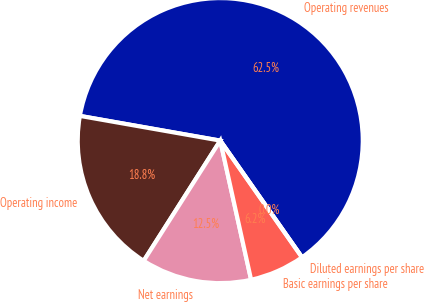Convert chart. <chart><loc_0><loc_0><loc_500><loc_500><pie_chart><fcel>Operating revenues<fcel>Operating income<fcel>Net earnings<fcel>Basic earnings per share<fcel>Diluted earnings per share<nl><fcel>62.5%<fcel>18.75%<fcel>12.5%<fcel>6.25%<fcel>0.0%<nl></chart> 